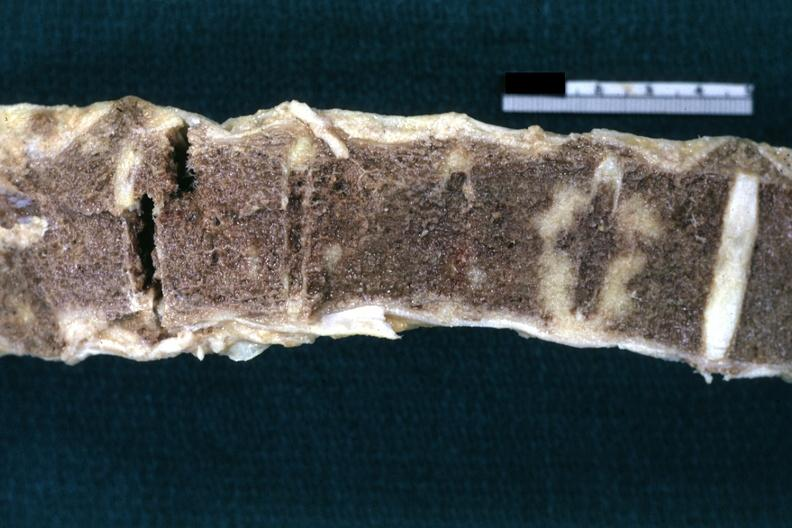what does this image show?
Answer the question using a single word or phrase. Fixed tissue nice example shown close-up 